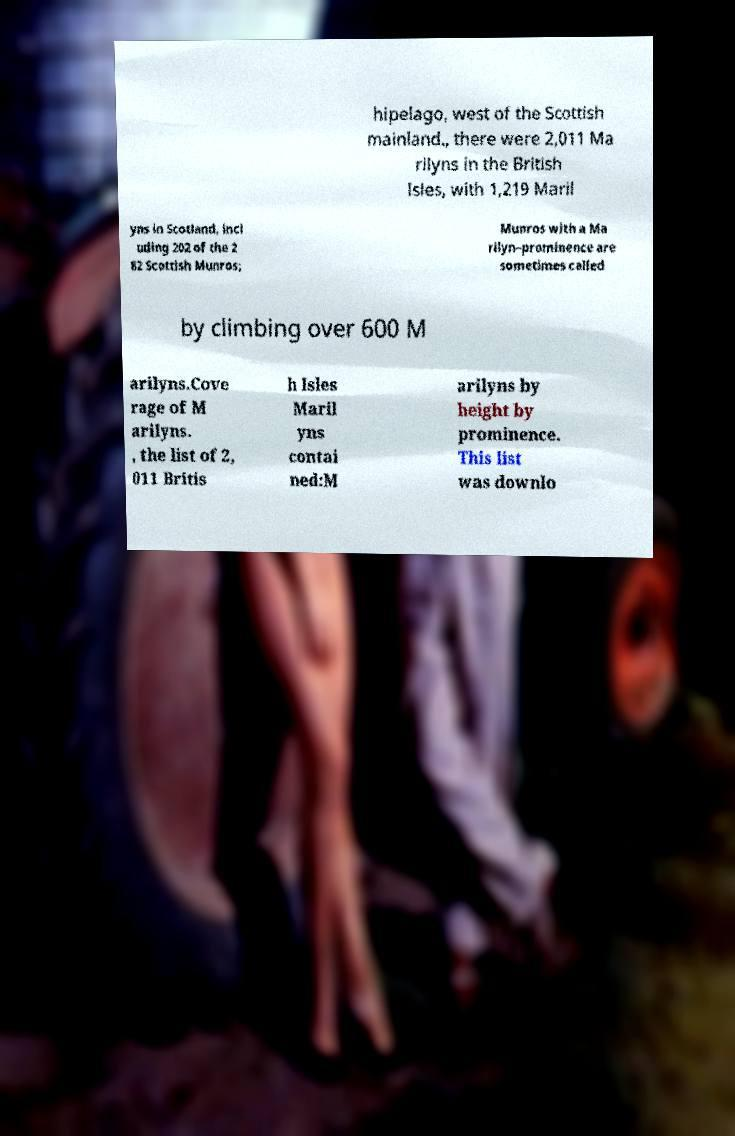Can you accurately transcribe the text from the provided image for me? hipelago, west of the Scottish mainland., there were 2,011 Ma rilyns in the British Isles, with 1,219 Maril yns in Scotland, incl uding 202 of the 2 82 Scottish Munros; Munros with a Ma rilyn–prominence are sometimes called by climbing over 600 M arilyns.Cove rage of M arilyns. , the list of 2, 011 Britis h Isles Maril yns contai ned:M arilyns by height by prominence. This list was downlo 